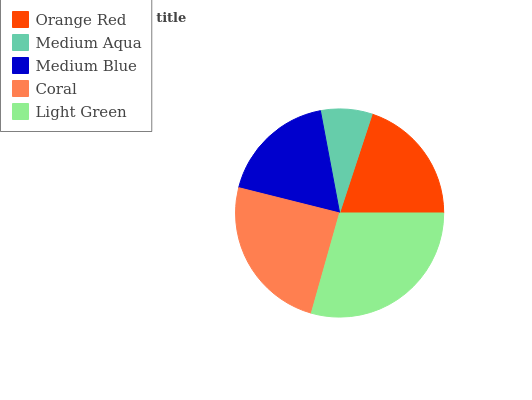Is Medium Aqua the minimum?
Answer yes or no. Yes. Is Light Green the maximum?
Answer yes or no. Yes. Is Medium Blue the minimum?
Answer yes or no. No. Is Medium Blue the maximum?
Answer yes or no. No. Is Medium Blue greater than Medium Aqua?
Answer yes or no. Yes. Is Medium Aqua less than Medium Blue?
Answer yes or no. Yes. Is Medium Aqua greater than Medium Blue?
Answer yes or no. No. Is Medium Blue less than Medium Aqua?
Answer yes or no. No. Is Orange Red the high median?
Answer yes or no. Yes. Is Orange Red the low median?
Answer yes or no. Yes. Is Light Green the high median?
Answer yes or no. No. Is Coral the low median?
Answer yes or no. No. 